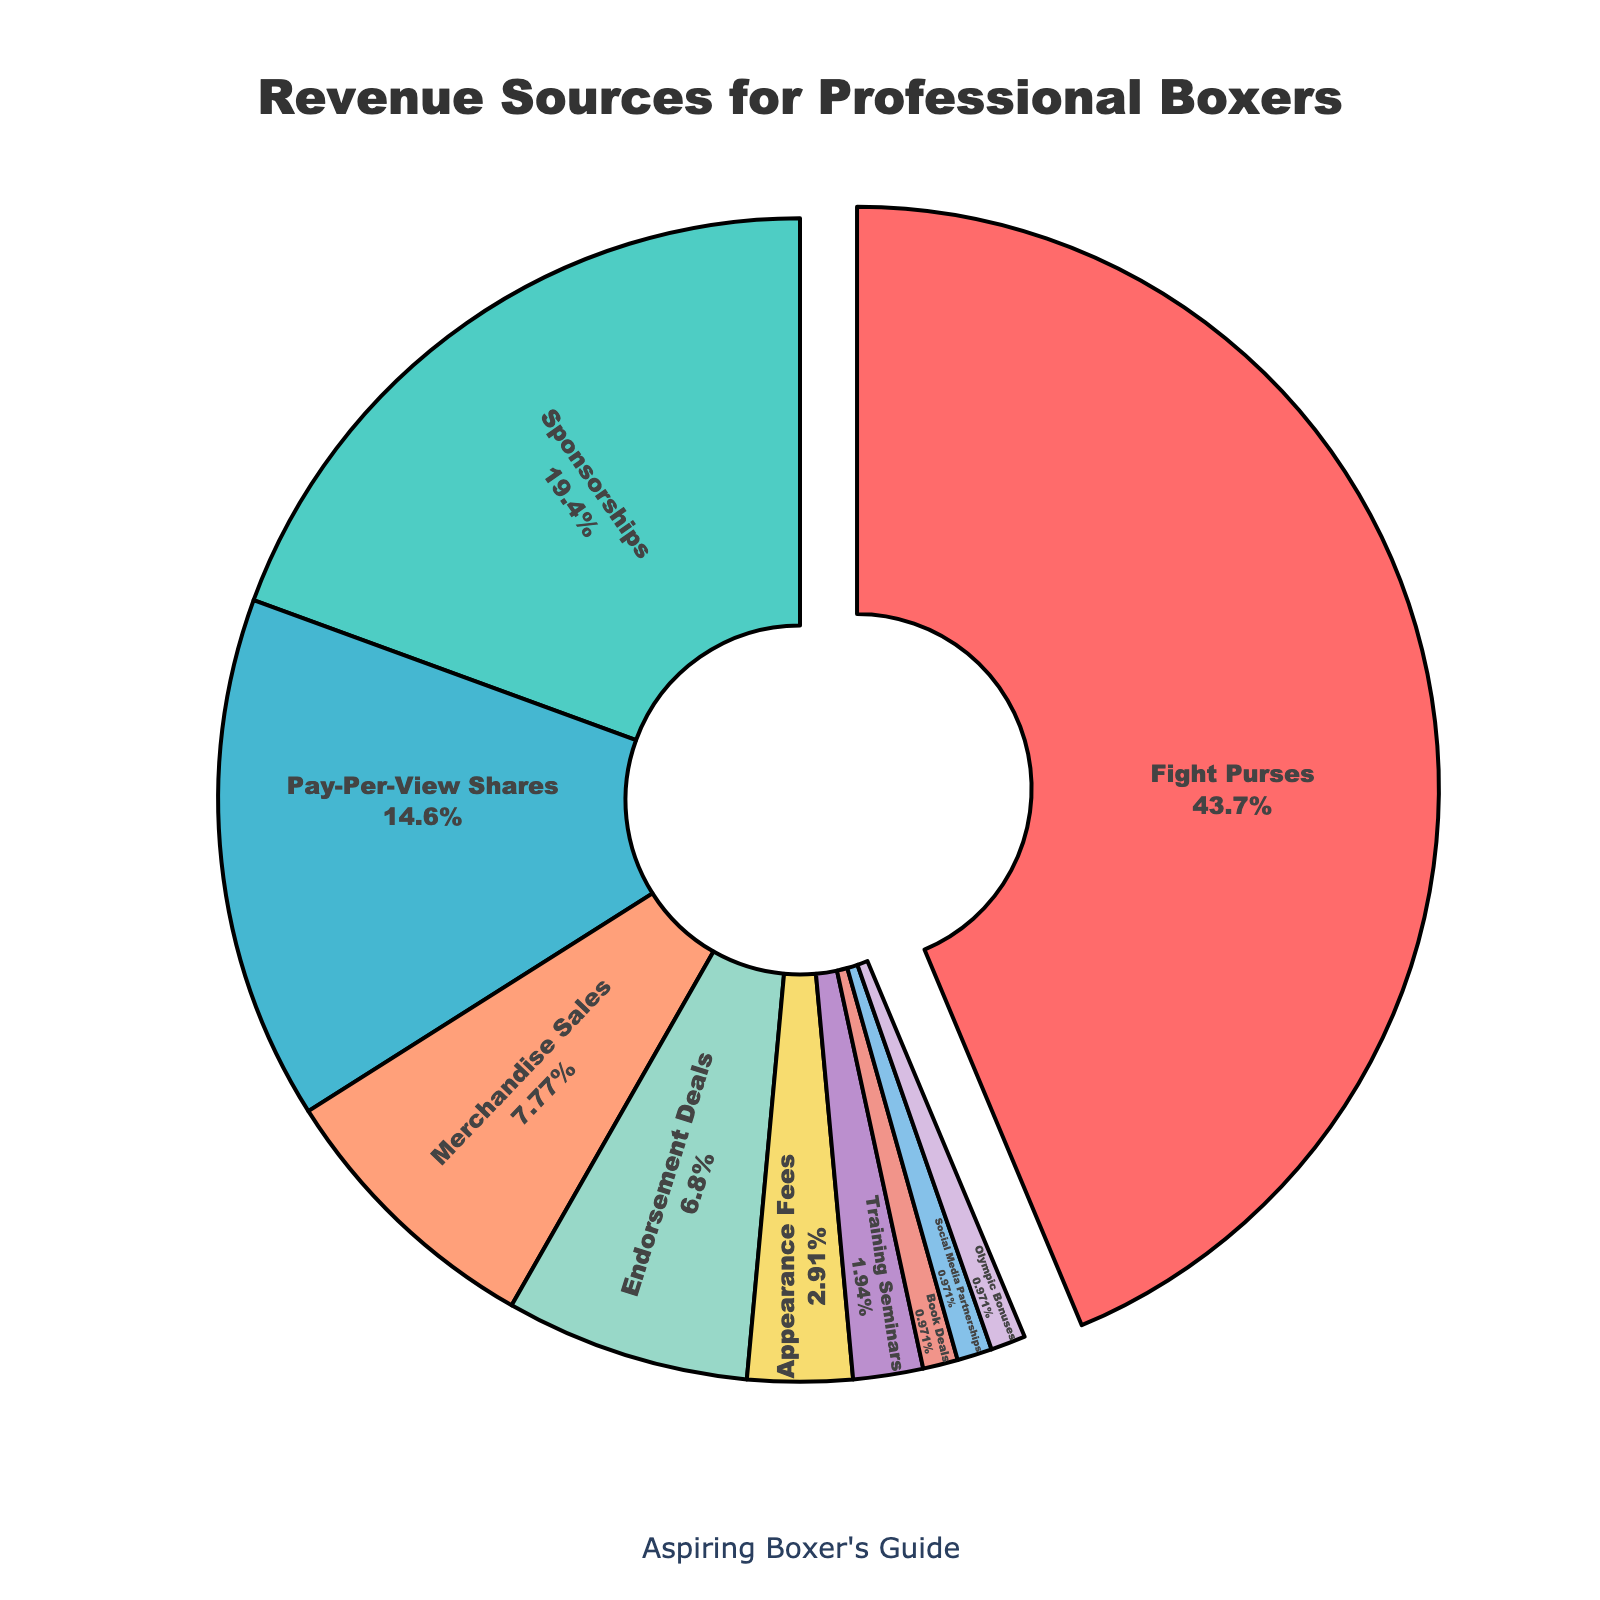Which revenue source contributes the highest percentage to professional boxers' earnings? From the pie chart, the largest segment corresponds to "Fight Purses," and it is pulled slightly away from the pie, indicating its prominence. The percentage associated with "Fight Purses" is the highest.
Answer: Fight Purses What percentage of earnings come from "Endorsement Deals" and "Appearance Fees" combined? From the pie chart, "Endorsement Deals" contribute 7% and "Appearance Fees" contribute 3%. Adding these percentages together: 7% + 3% = 10%.
Answer: 10% Are there more earnings from "Merchandise Sales" or "Pay-Per-View Shares"? Comparing the pie chart segments for "Merchandise Sales" and "Pay-Per-View Shares," the "Pay-Per-View Shares" segment is larger which indicates it contributes more to earnings.
Answer: Pay-Per-View Shares How does the percentage of earnings from "Sponsorships" compare to the combined percentage from "Training Seminars" and "Book Deals"? The percentage of earnings from "Sponsorships" is 20%. The combined percentage from "Training Seminars" and "Book Deals" is 2% + 1% = 3%. Comparing these, 20% (Sponsorships) is significantly greater than 3% (Training Seminars + Book Deals).
Answer: Sponsorships have a greater percentage What are the earnings from "Social Media Partnerships" as a percentage of the total earnings? From the pie chart, the segment labeled "Social Media Partnerships" corresponds to a 1% contribution to the total earnings.
Answer: 1% Which two revenue sources combined account for just over half of a professional boxer's earnings? The two largest segments in the pie chart are "Fight Purses" at 45% and "Sponsorships" at 20%. Adding these together: 45% + 20% = 65%, which is over half of the earnings.
Answer: Fight Purses and Sponsorships What visual annotation signifies the most significant revenue source in the pie chart? The segment for the most significant revenue source, "Fight Purses," is visually pulled slightly away from the center of the pie chart, emphasizing its importance.
Answer: Pulled segment If you exclude "Fight Purses," what is the next largest single source of earnings? After excluding "Fight Purses" which is the largest at 45%, the next largest segment is "Sponsorships" at 20%.
Answer: Sponsorships What combined percentage of revenue do the smallest three segments constitute? The smallest three segments are "Training Seminars," "Book Deals," and "Social Media Partnerships" each at 1%. Summing these gives: 1% + 1% + 1% = 3%.
Answer: 3% How much smaller is the contribution of "Merchandise Sales" compared to "Fight Purses"? "Merchandise Sales" contribute 8% while "Fight Purses" contribute 45%. The difference is 45% - 8% = 37%.
Answer: 37% 